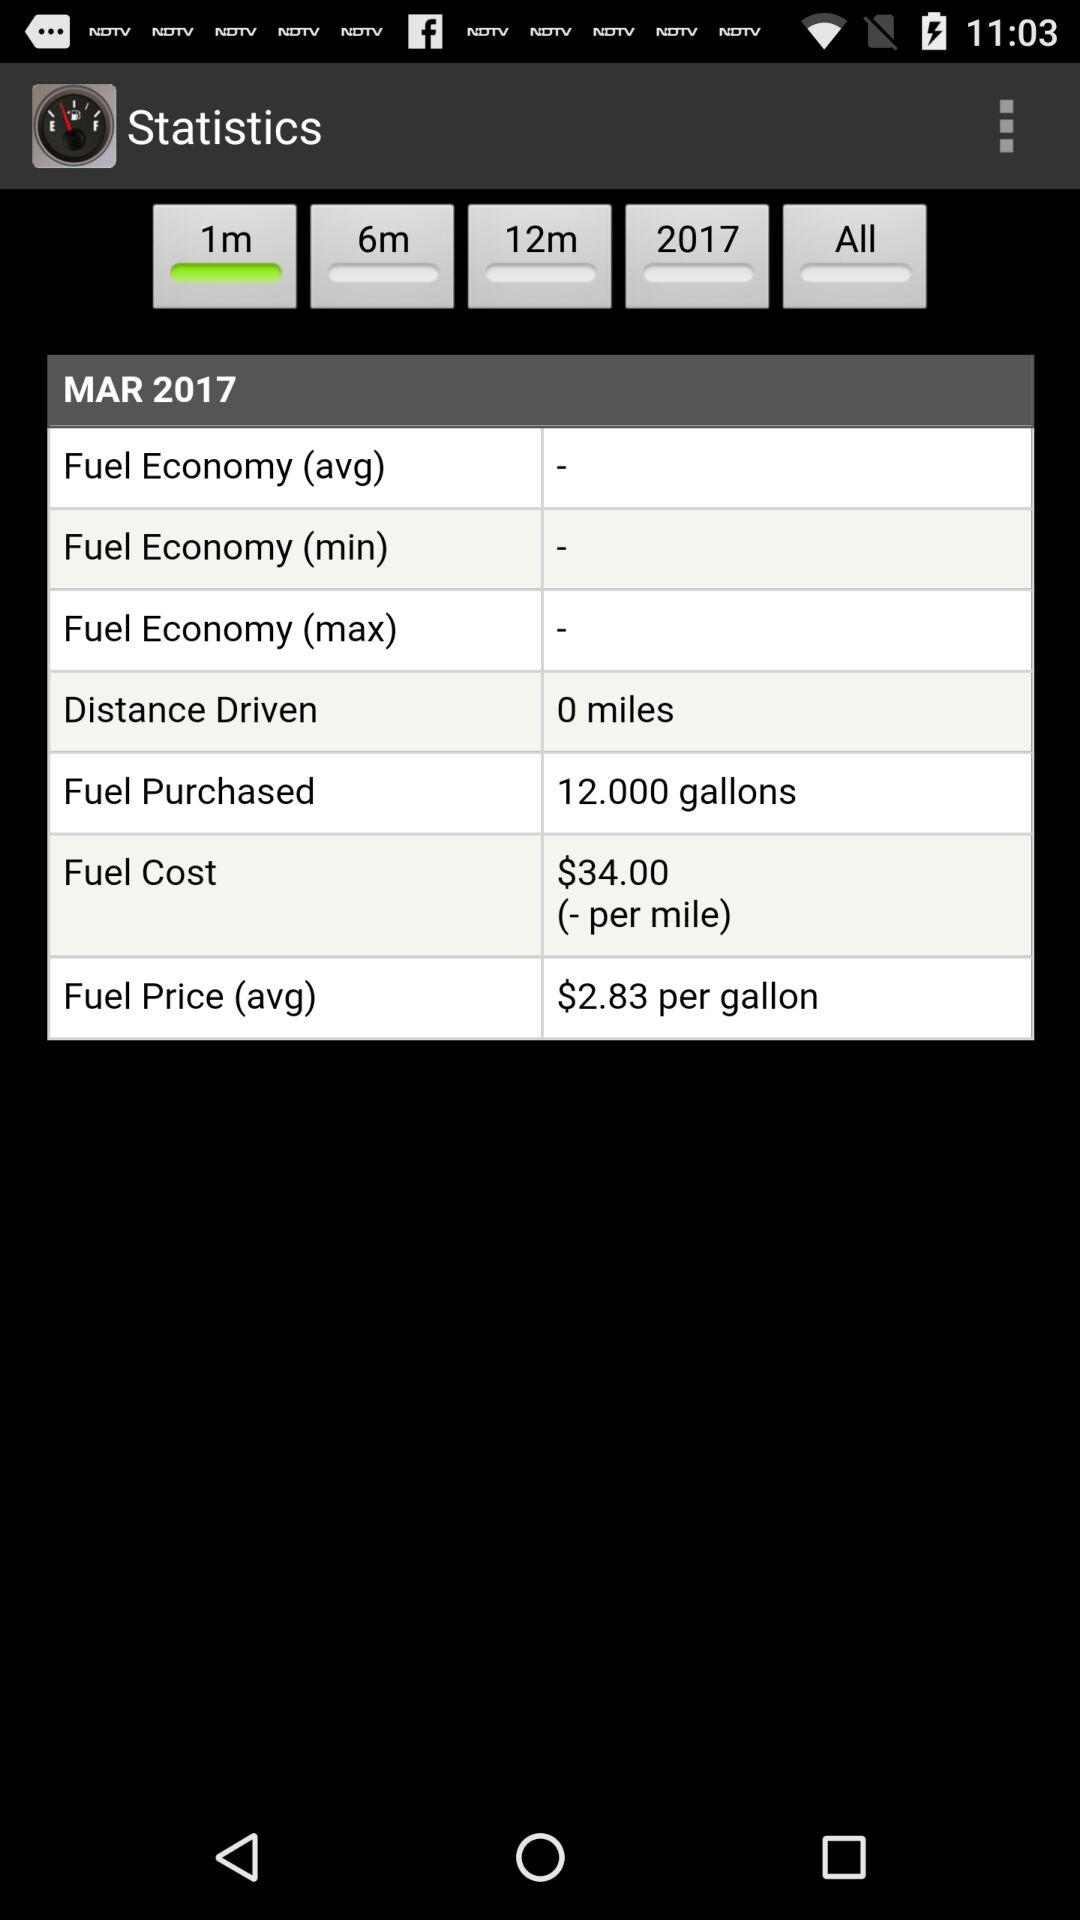How much is the fuel purchased? The purchased fuel is 12 gallons. 